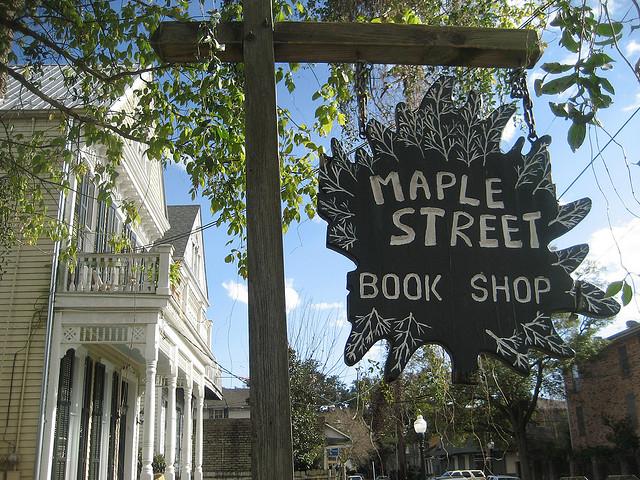Does the building have a balcony?
Concise answer only. Yes. What street is the bookshop on?
Quick response, please. Maple street. Is this in France?
Write a very short answer. No. How many signs are there on the post?
Write a very short answer. 1. Where was this photo taken?
Quick response, please. Maple street. What color is the book shop's building?
Write a very short answer. White. 